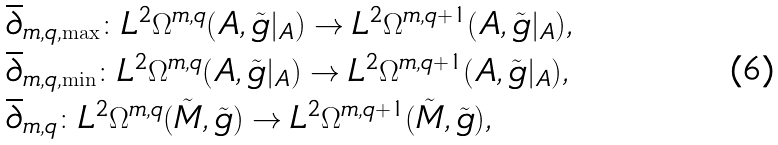<formula> <loc_0><loc_0><loc_500><loc_500>& \overline { \partial } _ { m , q , \max } \colon L ^ { 2 } \Omega ^ { m , q } ( A , \tilde { g } | _ { A } ) \rightarrow L ^ { 2 } \Omega ^ { m , q + 1 } ( A , \tilde { g } | _ { A } ) , \\ & \overline { \partial } _ { m , q , \min } \colon L ^ { 2 } \Omega ^ { m , q } ( A , \tilde { g } | _ { A } ) \rightarrow L ^ { 2 } \Omega ^ { m , q + 1 } ( A , \tilde { g } | _ { A } ) , \\ & \overline { \partial } _ { m , q } \colon L ^ { 2 } \Omega ^ { m , q } ( \tilde { M } , \tilde { g } ) \rightarrow L ^ { 2 } \Omega ^ { m , q + 1 } ( \tilde { M } , \tilde { g } ) ,</formula> 